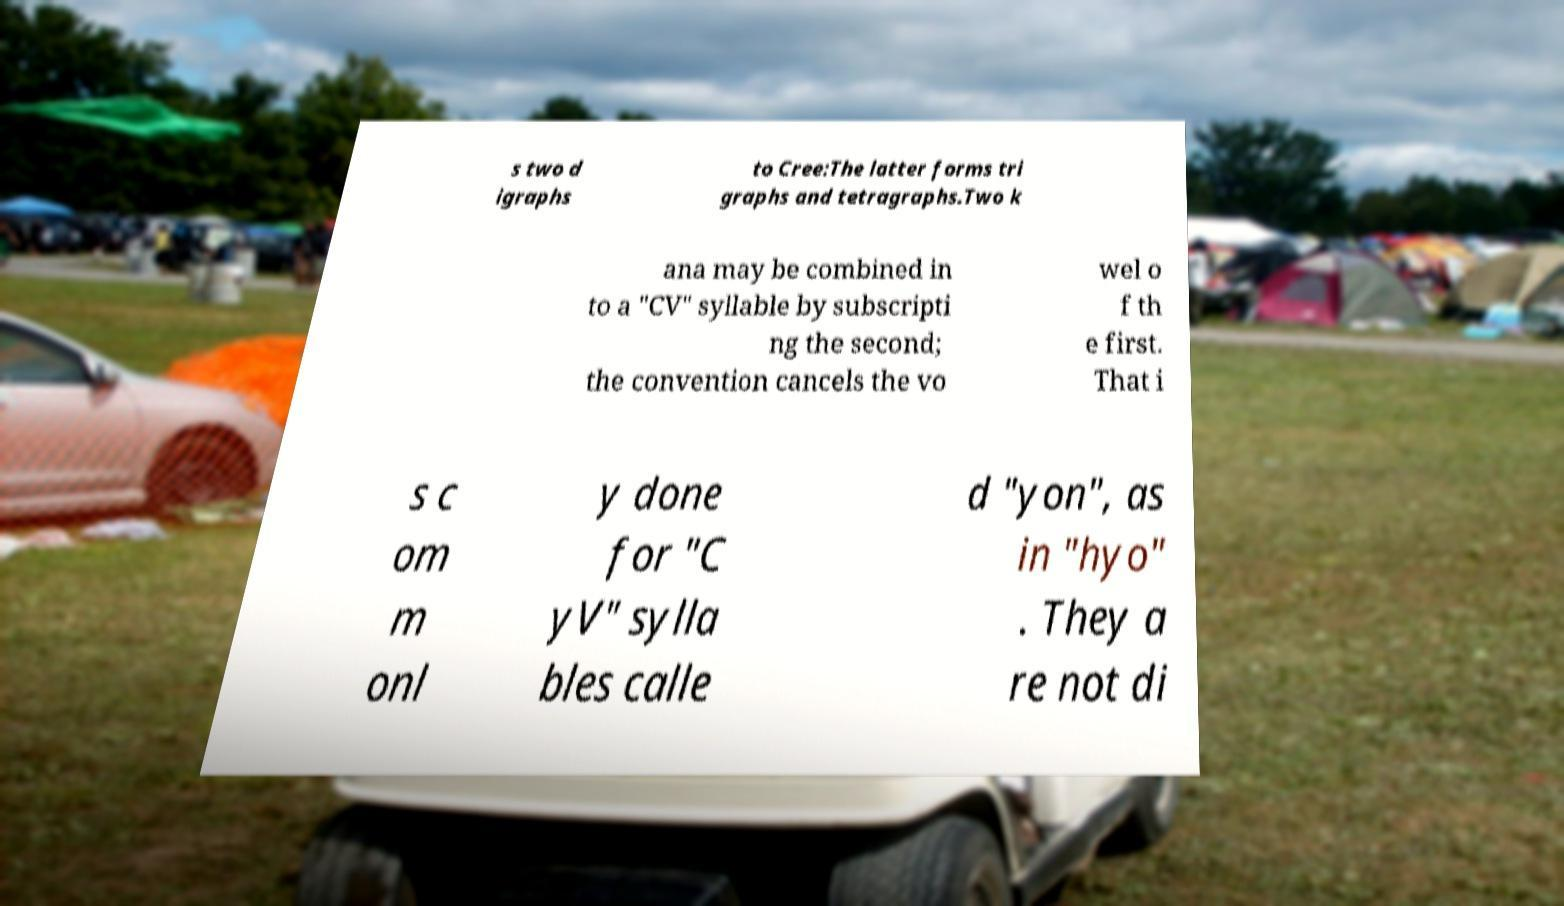Please read and relay the text visible in this image. What does it say? s two d igraphs to Cree:The latter forms tri graphs and tetragraphs.Two k ana may be combined in to a "CV" syllable by subscripti ng the second; the convention cancels the vo wel o f th e first. That i s c om m onl y done for "C yV" sylla bles calle d "yon", as in "hyo" . They a re not di 